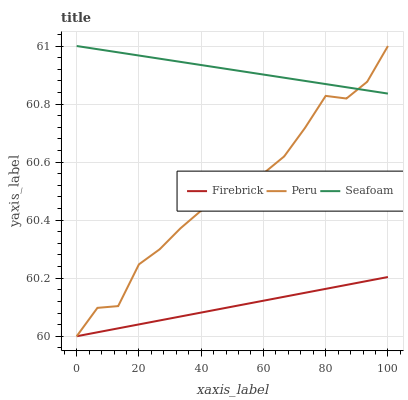Does Firebrick have the minimum area under the curve?
Answer yes or no. Yes. Does Seafoam have the maximum area under the curve?
Answer yes or no. Yes. Does Peru have the minimum area under the curve?
Answer yes or no. No. Does Peru have the maximum area under the curve?
Answer yes or no. No. Is Firebrick the smoothest?
Answer yes or no. Yes. Is Peru the roughest?
Answer yes or no. Yes. Is Seafoam the smoothest?
Answer yes or no. No. Is Seafoam the roughest?
Answer yes or no. No. Does Seafoam have the lowest value?
Answer yes or no. No. Is Firebrick less than Seafoam?
Answer yes or no. Yes. Is Seafoam greater than Firebrick?
Answer yes or no. Yes. Does Firebrick intersect Seafoam?
Answer yes or no. No. 